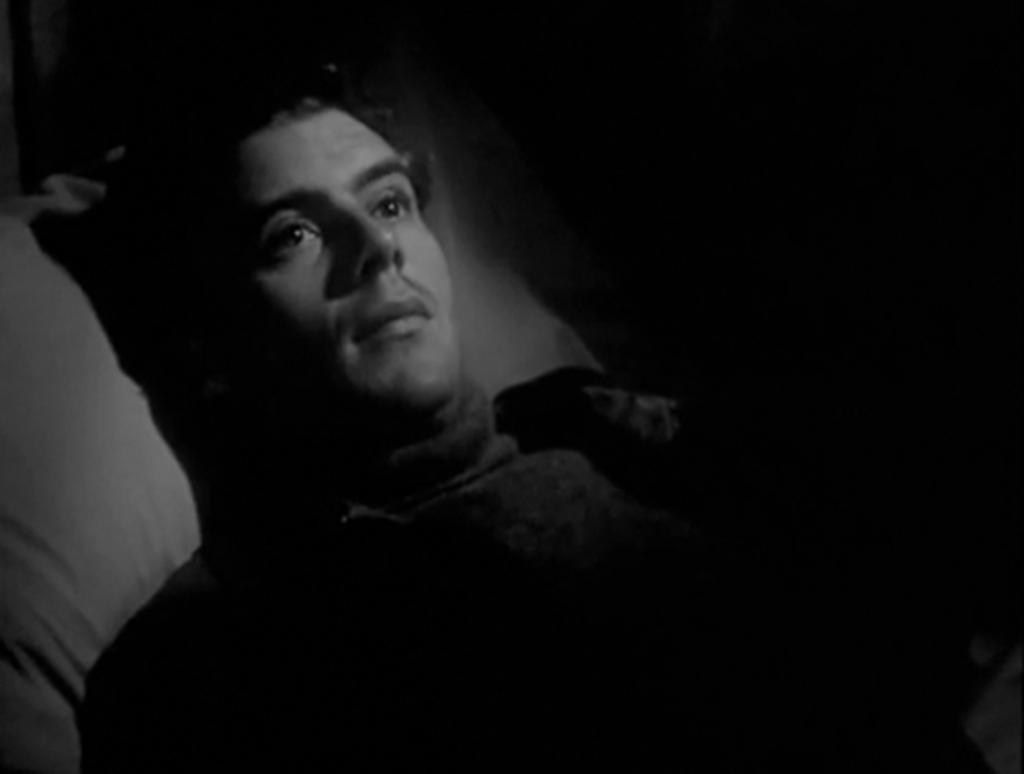What is the position of the man in the image? The man is lying in the image. What object is located at the bottom of the image? There is a pillow at the bottom of the image. What color is the background of the image? The background of the image is black. What type of berry is the man eating in the image? There is no berry present in the image, and the man is not eating anything. 